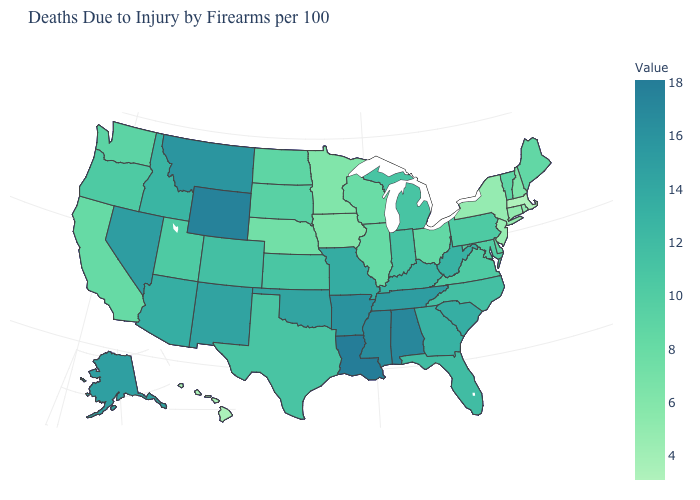Is the legend a continuous bar?
Write a very short answer. Yes. Which states have the highest value in the USA?
Write a very short answer. Louisiana. Which states have the lowest value in the USA?
Write a very short answer. Massachusetts. Which states have the lowest value in the USA?
Answer briefly. Massachusetts. Does Louisiana have the highest value in the USA?
Quick response, please. Yes. Among the states that border South Carolina , which have the lowest value?
Quick response, please. North Carolina. 